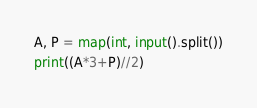<code> <loc_0><loc_0><loc_500><loc_500><_Python_>A, P = map(int, input().split())
print((A*3+P)//2)
</code> 